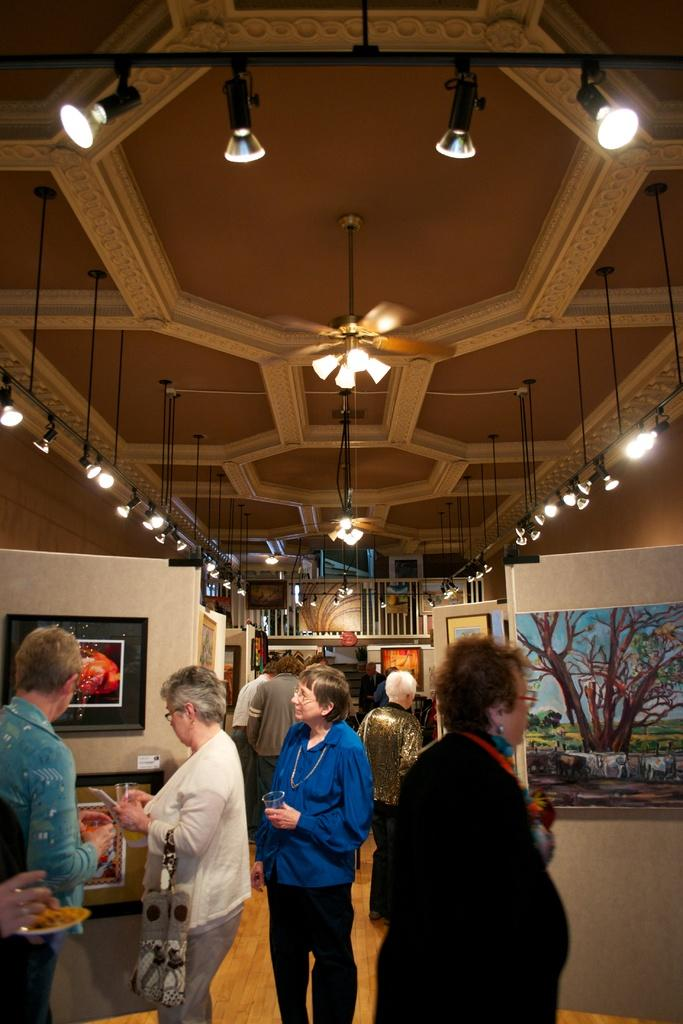What is present in the room in the image? There are people in the room. What can be seen on the walls in the image? There are painted frames on boards visible in the image. What is providing illumination in the room? There are lights on the roof. What type of pen is being used by the people in the image? There is no pen visible in the image; the people are not shown holding or using any writing instruments. 